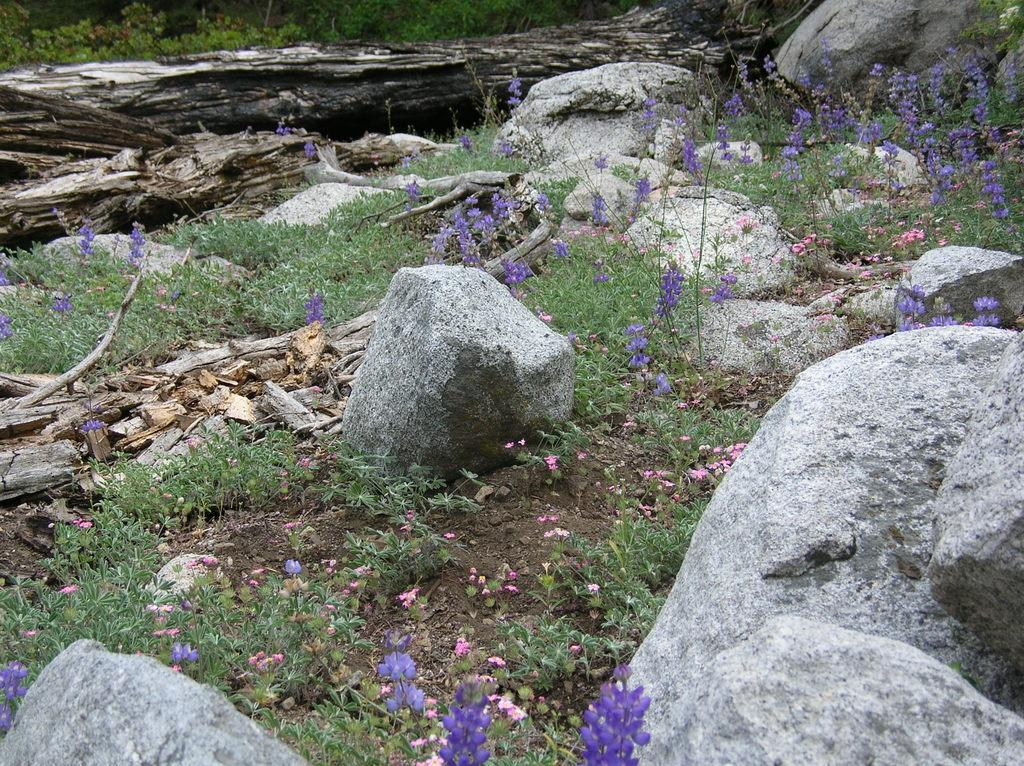What type of natural elements can be seen in the image? There are stones and grass visible in the image. What color are the flowers in the image? The flowers in the image are violet-colored. What can be seen in the background of the image? There are tree poles in the background of the image. What type of cabbage is being served by the maid in the image? There is no maid or cabbage present in the image. 